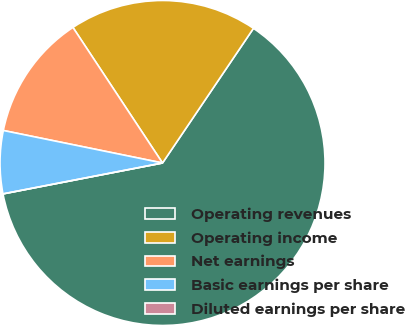<chart> <loc_0><loc_0><loc_500><loc_500><pie_chart><fcel>Operating revenues<fcel>Operating income<fcel>Net earnings<fcel>Basic earnings per share<fcel>Diluted earnings per share<nl><fcel>62.5%<fcel>18.75%<fcel>12.5%<fcel>6.25%<fcel>0.0%<nl></chart> 